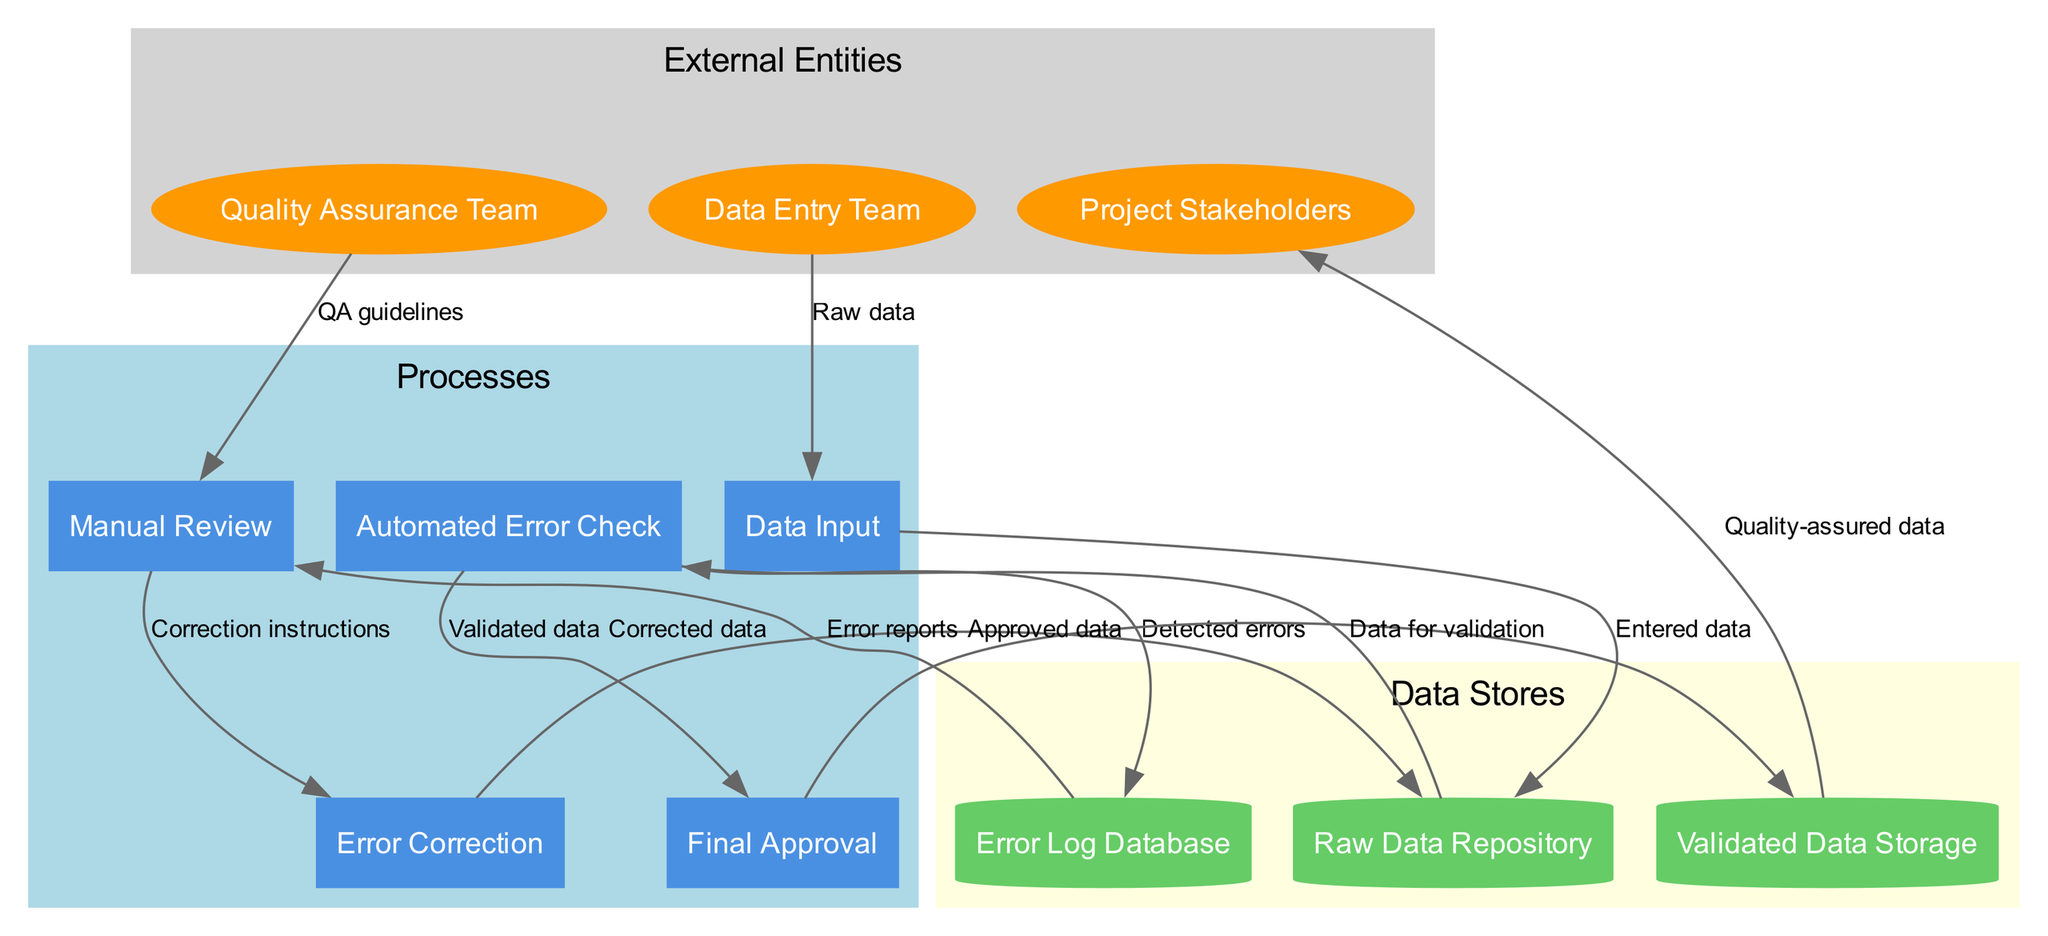What is the first external entity in the diagram? The first external entity listed in the diagram is "Data Entry Team," as it appears at the top among the external entities.
Answer: Data Entry Team How many processes are shown in the diagram? The diagram displays a total of five processes: Data Input, Automated Error Check, Manual Review, Error Correction, and Final Approval. Counting these processes gives us the total.
Answer: 5 What type of data store holds the error reports? The error reports are stored in the "Error Log Database," as indicated by the flow from the "Automated Error Check" to the data store.
Answer: Error Log Database Which team provides guidelines for the manual review process? The "Quality Assurance Team" provides QA guidelines for the Manual Review process, as shown by the flow from the Quality Assurance Team to Manual Review.
Answer: Quality Assurance Team What occurs after the "Error Correction" process? After "Error Correction," the corrected data flows back to the "Raw Data Repository," indicating that corrected entries are reentered into the system.
Answer: Raw Data Repository What is the final output of the system? The final output of the system is "Quality-assured data," which is sent to the Project Stakeholders. The flow from Validated Data Storage to Project Stakeholders highlights this output.
Answer: Quality-assured data What does the "Automated Error Check" process provide to the "Final Approval" process? The "Automated Error Check" provides "Validated data" to the "Final Approval" process, confirming that the data has passed automated checks before final validation.
Answer: Validated data How is corrected data handled in the system? "Corrected data" is sent from the "Error Correction" process back to the "Raw Data Repository," indicating that the errors have been addressed and the data has been corrected before proceeding.
Answer: Raw Data Repository What type of data store is "Validated Data Storage"? "Validated Data Storage" is categorized as a cylinder in the diagram, which denotes it as a data store that holds the approved data after the final approval process.
Answer: Cylinder 